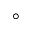Convert formula to latex. <formula><loc_0><loc_0><loc_500><loc_500>\circ</formula> 